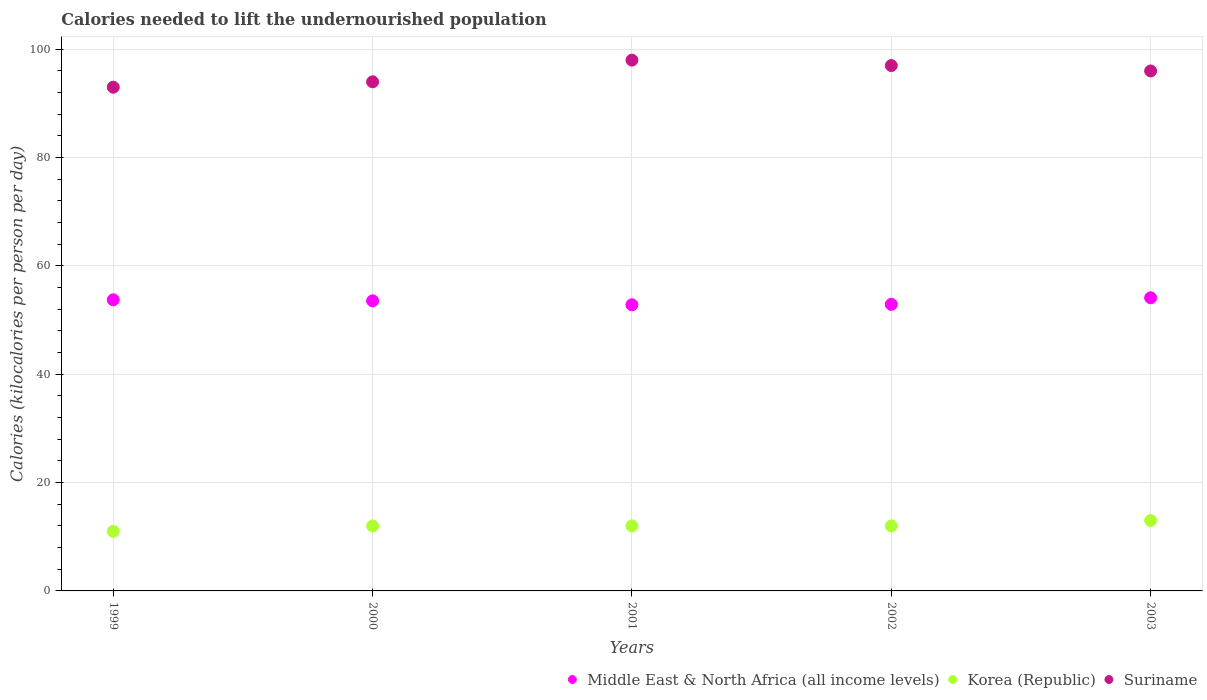What is the total calories needed to lift the undernourished population in Middle East & North Africa (all income levels) in 2001?
Your answer should be very brief. 52.83. Across all years, what is the maximum total calories needed to lift the undernourished population in Korea (Republic)?
Your answer should be very brief. 13. Across all years, what is the minimum total calories needed to lift the undernourished population in Suriname?
Provide a succinct answer. 93. In which year was the total calories needed to lift the undernourished population in Middle East & North Africa (all income levels) minimum?
Your answer should be compact. 2001. What is the total total calories needed to lift the undernourished population in Suriname in the graph?
Offer a very short reply. 478. What is the difference between the total calories needed to lift the undernourished population in Middle East & North Africa (all income levels) in 2002 and the total calories needed to lift the undernourished population in Korea (Republic) in 2000?
Keep it short and to the point. 40.91. In the year 2002, what is the difference between the total calories needed to lift the undernourished population in Middle East & North Africa (all income levels) and total calories needed to lift the undernourished population in Korea (Republic)?
Give a very brief answer. 40.91. What is the ratio of the total calories needed to lift the undernourished population in Suriname in 1999 to that in 2003?
Your answer should be compact. 0.97. What is the difference between the highest and the second highest total calories needed to lift the undernourished population in Middle East & North Africa (all income levels)?
Give a very brief answer. 0.37. What is the difference between the highest and the lowest total calories needed to lift the undernourished population in Korea (Republic)?
Offer a terse response. 2. In how many years, is the total calories needed to lift the undernourished population in Korea (Republic) greater than the average total calories needed to lift the undernourished population in Korea (Republic) taken over all years?
Provide a succinct answer. 1. Is the sum of the total calories needed to lift the undernourished population in Middle East & North Africa (all income levels) in 1999 and 2000 greater than the maximum total calories needed to lift the undernourished population in Korea (Republic) across all years?
Provide a short and direct response. Yes. Is the total calories needed to lift the undernourished population in Middle East & North Africa (all income levels) strictly less than the total calories needed to lift the undernourished population in Korea (Republic) over the years?
Ensure brevity in your answer.  No. How many dotlines are there?
Keep it short and to the point. 3. How many years are there in the graph?
Your answer should be compact. 5. Are the values on the major ticks of Y-axis written in scientific E-notation?
Your response must be concise. No. Does the graph contain any zero values?
Make the answer very short. No. Does the graph contain grids?
Your answer should be very brief. Yes. How many legend labels are there?
Provide a short and direct response. 3. What is the title of the graph?
Your answer should be very brief. Calories needed to lift the undernourished population. What is the label or title of the X-axis?
Provide a succinct answer. Years. What is the label or title of the Y-axis?
Ensure brevity in your answer.  Calories (kilocalories per person per day). What is the Calories (kilocalories per person per day) of Middle East & North Africa (all income levels) in 1999?
Your answer should be compact. 53.75. What is the Calories (kilocalories per person per day) of Korea (Republic) in 1999?
Keep it short and to the point. 11. What is the Calories (kilocalories per person per day) of Suriname in 1999?
Offer a very short reply. 93. What is the Calories (kilocalories per person per day) in Middle East & North Africa (all income levels) in 2000?
Your answer should be very brief. 53.56. What is the Calories (kilocalories per person per day) in Suriname in 2000?
Your answer should be very brief. 94. What is the Calories (kilocalories per person per day) of Middle East & North Africa (all income levels) in 2001?
Your answer should be very brief. 52.83. What is the Calories (kilocalories per person per day) of Suriname in 2001?
Give a very brief answer. 98. What is the Calories (kilocalories per person per day) of Middle East & North Africa (all income levels) in 2002?
Keep it short and to the point. 52.91. What is the Calories (kilocalories per person per day) in Suriname in 2002?
Provide a short and direct response. 97. What is the Calories (kilocalories per person per day) of Middle East & North Africa (all income levels) in 2003?
Your answer should be compact. 54.12. What is the Calories (kilocalories per person per day) of Korea (Republic) in 2003?
Ensure brevity in your answer.  13. What is the Calories (kilocalories per person per day) in Suriname in 2003?
Provide a short and direct response. 96. Across all years, what is the maximum Calories (kilocalories per person per day) of Middle East & North Africa (all income levels)?
Your answer should be compact. 54.12. Across all years, what is the minimum Calories (kilocalories per person per day) of Middle East & North Africa (all income levels)?
Your answer should be very brief. 52.83. Across all years, what is the minimum Calories (kilocalories per person per day) of Korea (Republic)?
Offer a terse response. 11. Across all years, what is the minimum Calories (kilocalories per person per day) of Suriname?
Ensure brevity in your answer.  93. What is the total Calories (kilocalories per person per day) in Middle East & North Africa (all income levels) in the graph?
Your response must be concise. 267.17. What is the total Calories (kilocalories per person per day) in Korea (Republic) in the graph?
Offer a very short reply. 60. What is the total Calories (kilocalories per person per day) in Suriname in the graph?
Offer a very short reply. 478. What is the difference between the Calories (kilocalories per person per day) of Middle East & North Africa (all income levels) in 1999 and that in 2000?
Make the answer very short. 0.19. What is the difference between the Calories (kilocalories per person per day) of Korea (Republic) in 1999 and that in 2000?
Ensure brevity in your answer.  -1. What is the difference between the Calories (kilocalories per person per day) of Middle East & North Africa (all income levels) in 1999 and that in 2001?
Offer a very short reply. 0.92. What is the difference between the Calories (kilocalories per person per day) in Middle East & North Africa (all income levels) in 1999 and that in 2002?
Ensure brevity in your answer.  0.84. What is the difference between the Calories (kilocalories per person per day) in Korea (Republic) in 1999 and that in 2002?
Provide a short and direct response. -1. What is the difference between the Calories (kilocalories per person per day) in Suriname in 1999 and that in 2002?
Ensure brevity in your answer.  -4. What is the difference between the Calories (kilocalories per person per day) of Middle East & North Africa (all income levels) in 1999 and that in 2003?
Offer a very short reply. -0.37. What is the difference between the Calories (kilocalories per person per day) of Suriname in 1999 and that in 2003?
Offer a terse response. -3. What is the difference between the Calories (kilocalories per person per day) in Middle East & North Africa (all income levels) in 2000 and that in 2001?
Your response must be concise. 0.72. What is the difference between the Calories (kilocalories per person per day) of Korea (Republic) in 2000 and that in 2001?
Provide a succinct answer. 0. What is the difference between the Calories (kilocalories per person per day) of Suriname in 2000 and that in 2001?
Give a very brief answer. -4. What is the difference between the Calories (kilocalories per person per day) of Middle East & North Africa (all income levels) in 2000 and that in 2002?
Ensure brevity in your answer.  0.65. What is the difference between the Calories (kilocalories per person per day) of Korea (Republic) in 2000 and that in 2002?
Provide a succinct answer. 0. What is the difference between the Calories (kilocalories per person per day) of Suriname in 2000 and that in 2002?
Your response must be concise. -3. What is the difference between the Calories (kilocalories per person per day) in Middle East & North Africa (all income levels) in 2000 and that in 2003?
Your answer should be very brief. -0.57. What is the difference between the Calories (kilocalories per person per day) in Korea (Republic) in 2000 and that in 2003?
Provide a short and direct response. -1. What is the difference between the Calories (kilocalories per person per day) of Middle East & North Africa (all income levels) in 2001 and that in 2002?
Offer a very short reply. -0.08. What is the difference between the Calories (kilocalories per person per day) in Suriname in 2001 and that in 2002?
Offer a very short reply. 1. What is the difference between the Calories (kilocalories per person per day) in Middle East & North Africa (all income levels) in 2001 and that in 2003?
Make the answer very short. -1.29. What is the difference between the Calories (kilocalories per person per day) in Suriname in 2001 and that in 2003?
Offer a very short reply. 2. What is the difference between the Calories (kilocalories per person per day) of Middle East & North Africa (all income levels) in 2002 and that in 2003?
Keep it short and to the point. -1.21. What is the difference between the Calories (kilocalories per person per day) of Middle East & North Africa (all income levels) in 1999 and the Calories (kilocalories per person per day) of Korea (Republic) in 2000?
Provide a succinct answer. 41.75. What is the difference between the Calories (kilocalories per person per day) of Middle East & North Africa (all income levels) in 1999 and the Calories (kilocalories per person per day) of Suriname in 2000?
Keep it short and to the point. -40.25. What is the difference between the Calories (kilocalories per person per day) in Korea (Republic) in 1999 and the Calories (kilocalories per person per day) in Suriname in 2000?
Your response must be concise. -83. What is the difference between the Calories (kilocalories per person per day) in Middle East & North Africa (all income levels) in 1999 and the Calories (kilocalories per person per day) in Korea (Republic) in 2001?
Offer a very short reply. 41.75. What is the difference between the Calories (kilocalories per person per day) of Middle East & North Africa (all income levels) in 1999 and the Calories (kilocalories per person per day) of Suriname in 2001?
Your response must be concise. -44.25. What is the difference between the Calories (kilocalories per person per day) in Korea (Republic) in 1999 and the Calories (kilocalories per person per day) in Suriname in 2001?
Make the answer very short. -87. What is the difference between the Calories (kilocalories per person per day) of Middle East & North Africa (all income levels) in 1999 and the Calories (kilocalories per person per day) of Korea (Republic) in 2002?
Offer a terse response. 41.75. What is the difference between the Calories (kilocalories per person per day) of Middle East & North Africa (all income levels) in 1999 and the Calories (kilocalories per person per day) of Suriname in 2002?
Your answer should be very brief. -43.25. What is the difference between the Calories (kilocalories per person per day) in Korea (Republic) in 1999 and the Calories (kilocalories per person per day) in Suriname in 2002?
Provide a short and direct response. -86. What is the difference between the Calories (kilocalories per person per day) of Middle East & North Africa (all income levels) in 1999 and the Calories (kilocalories per person per day) of Korea (Republic) in 2003?
Ensure brevity in your answer.  40.75. What is the difference between the Calories (kilocalories per person per day) in Middle East & North Africa (all income levels) in 1999 and the Calories (kilocalories per person per day) in Suriname in 2003?
Offer a terse response. -42.25. What is the difference between the Calories (kilocalories per person per day) of Korea (Republic) in 1999 and the Calories (kilocalories per person per day) of Suriname in 2003?
Keep it short and to the point. -85. What is the difference between the Calories (kilocalories per person per day) in Middle East & North Africa (all income levels) in 2000 and the Calories (kilocalories per person per day) in Korea (Republic) in 2001?
Your response must be concise. 41.56. What is the difference between the Calories (kilocalories per person per day) of Middle East & North Africa (all income levels) in 2000 and the Calories (kilocalories per person per day) of Suriname in 2001?
Provide a succinct answer. -44.44. What is the difference between the Calories (kilocalories per person per day) of Korea (Republic) in 2000 and the Calories (kilocalories per person per day) of Suriname in 2001?
Make the answer very short. -86. What is the difference between the Calories (kilocalories per person per day) in Middle East & North Africa (all income levels) in 2000 and the Calories (kilocalories per person per day) in Korea (Republic) in 2002?
Offer a very short reply. 41.56. What is the difference between the Calories (kilocalories per person per day) in Middle East & North Africa (all income levels) in 2000 and the Calories (kilocalories per person per day) in Suriname in 2002?
Provide a short and direct response. -43.44. What is the difference between the Calories (kilocalories per person per day) of Korea (Republic) in 2000 and the Calories (kilocalories per person per day) of Suriname in 2002?
Provide a succinct answer. -85. What is the difference between the Calories (kilocalories per person per day) of Middle East & North Africa (all income levels) in 2000 and the Calories (kilocalories per person per day) of Korea (Republic) in 2003?
Give a very brief answer. 40.56. What is the difference between the Calories (kilocalories per person per day) in Middle East & North Africa (all income levels) in 2000 and the Calories (kilocalories per person per day) in Suriname in 2003?
Keep it short and to the point. -42.44. What is the difference between the Calories (kilocalories per person per day) of Korea (Republic) in 2000 and the Calories (kilocalories per person per day) of Suriname in 2003?
Your answer should be compact. -84. What is the difference between the Calories (kilocalories per person per day) in Middle East & North Africa (all income levels) in 2001 and the Calories (kilocalories per person per day) in Korea (Republic) in 2002?
Provide a short and direct response. 40.83. What is the difference between the Calories (kilocalories per person per day) of Middle East & North Africa (all income levels) in 2001 and the Calories (kilocalories per person per day) of Suriname in 2002?
Offer a terse response. -44.17. What is the difference between the Calories (kilocalories per person per day) of Korea (Republic) in 2001 and the Calories (kilocalories per person per day) of Suriname in 2002?
Make the answer very short. -85. What is the difference between the Calories (kilocalories per person per day) in Middle East & North Africa (all income levels) in 2001 and the Calories (kilocalories per person per day) in Korea (Republic) in 2003?
Give a very brief answer. 39.83. What is the difference between the Calories (kilocalories per person per day) in Middle East & North Africa (all income levels) in 2001 and the Calories (kilocalories per person per day) in Suriname in 2003?
Ensure brevity in your answer.  -43.17. What is the difference between the Calories (kilocalories per person per day) in Korea (Republic) in 2001 and the Calories (kilocalories per person per day) in Suriname in 2003?
Provide a succinct answer. -84. What is the difference between the Calories (kilocalories per person per day) in Middle East & North Africa (all income levels) in 2002 and the Calories (kilocalories per person per day) in Korea (Republic) in 2003?
Keep it short and to the point. 39.91. What is the difference between the Calories (kilocalories per person per day) in Middle East & North Africa (all income levels) in 2002 and the Calories (kilocalories per person per day) in Suriname in 2003?
Your answer should be very brief. -43.09. What is the difference between the Calories (kilocalories per person per day) of Korea (Republic) in 2002 and the Calories (kilocalories per person per day) of Suriname in 2003?
Make the answer very short. -84. What is the average Calories (kilocalories per person per day) in Middle East & North Africa (all income levels) per year?
Keep it short and to the point. 53.43. What is the average Calories (kilocalories per person per day) of Korea (Republic) per year?
Your answer should be very brief. 12. What is the average Calories (kilocalories per person per day) of Suriname per year?
Your answer should be very brief. 95.6. In the year 1999, what is the difference between the Calories (kilocalories per person per day) of Middle East & North Africa (all income levels) and Calories (kilocalories per person per day) of Korea (Republic)?
Offer a terse response. 42.75. In the year 1999, what is the difference between the Calories (kilocalories per person per day) in Middle East & North Africa (all income levels) and Calories (kilocalories per person per day) in Suriname?
Make the answer very short. -39.25. In the year 1999, what is the difference between the Calories (kilocalories per person per day) of Korea (Republic) and Calories (kilocalories per person per day) of Suriname?
Give a very brief answer. -82. In the year 2000, what is the difference between the Calories (kilocalories per person per day) in Middle East & North Africa (all income levels) and Calories (kilocalories per person per day) in Korea (Republic)?
Provide a succinct answer. 41.56. In the year 2000, what is the difference between the Calories (kilocalories per person per day) in Middle East & North Africa (all income levels) and Calories (kilocalories per person per day) in Suriname?
Provide a succinct answer. -40.44. In the year 2000, what is the difference between the Calories (kilocalories per person per day) of Korea (Republic) and Calories (kilocalories per person per day) of Suriname?
Ensure brevity in your answer.  -82. In the year 2001, what is the difference between the Calories (kilocalories per person per day) in Middle East & North Africa (all income levels) and Calories (kilocalories per person per day) in Korea (Republic)?
Your response must be concise. 40.83. In the year 2001, what is the difference between the Calories (kilocalories per person per day) in Middle East & North Africa (all income levels) and Calories (kilocalories per person per day) in Suriname?
Provide a succinct answer. -45.17. In the year 2001, what is the difference between the Calories (kilocalories per person per day) in Korea (Republic) and Calories (kilocalories per person per day) in Suriname?
Provide a succinct answer. -86. In the year 2002, what is the difference between the Calories (kilocalories per person per day) in Middle East & North Africa (all income levels) and Calories (kilocalories per person per day) in Korea (Republic)?
Keep it short and to the point. 40.91. In the year 2002, what is the difference between the Calories (kilocalories per person per day) in Middle East & North Africa (all income levels) and Calories (kilocalories per person per day) in Suriname?
Offer a terse response. -44.09. In the year 2002, what is the difference between the Calories (kilocalories per person per day) in Korea (Republic) and Calories (kilocalories per person per day) in Suriname?
Offer a very short reply. -85. In the year 2003, what is the difference between the Calories (kilocalories per person per day) in Middle East & North Africa (all income levels) and Calories (kilocalories per person per day) in Korea (Republic)?
Ensure brevity in your answer.  41.12. In the year 2003, what is the difference between the Calories (kilocalories per person per day) of Middle East & North Africa (all income levels) and Calories (kilocalories per person per day) of Suriname?
Offer a terse response. -41.88. In the year 2003, what is the difference between the Calories (kilocalories per person per day) of Korea (Republic) and Calories (kilocalories per person per day) of Suriname?
Make the answer very short. -83. What is the ratio of the Calories (kilocalories per person per day) of Korea (Republic) in 1999 to that in 2000?
Offer a very short reply. 0.92. What is the ratio of the Calories (kilocalories per person per day) in Middle East & North Africa (all income levels) in 1999 to that in 2001?
Your response must be concise. 1.02. What is the ratio of the Calories (kilocalories per person per day) in Suriname in 1999 to that in 2001?
Make the answer very short. 0.95. What is the ratio of the Calories (kilocalories per person per day) in Middle East & North Africa (all income levels) in 1999 to that in 2002?
Give a very brief answer. 1.02. What is the ratio of the Calories (kilocalories per person per day) of Korea (Republic) in 1999 to that in 2002?
Provide a succinct answer. 0.92. What is the ratio of the Calories (kilocalories per person per day) in Suriname in 1999 to that in 2002?
Offer a terse response. 0.96. What is the ratio of the Calories (kilocalories per person per day) in Middle East & North Africa (all income levels) in 1999 to that in 2003?
Give a very brief answer. 0.99. What is the ratio of the Calories (kilocalories per person per day) in Korea (Republic) in 1999 to that in 2003?
Offer a very short reply. 0.85. What is the ratio of the Calories (kilocalories per person per day) of Suriname in 1999 to that in 2003?
Ensure brevity in your answer.  0.97. What is the ratio of the Calories (kilocalories per person per day) in Middle East & North Africa (all income levels) in 2000 to that in 2001?
Ensure brevity in your answer.  1.01. What is the ratio of the Calories (kilocalories per person per day) of Suriname in 2000 to that in 2001?
Your answer should be very brief. 0.96. What is the ratio of the Calories (kilocalories per person per day) in Middle East & North Africa (all income levels) in 2000 to that in 2002?
Offer a very short reply. 1.01. What is the ratio of the Calories (kilocalories per person per day) in Korea (Republic) in 2000 to that in 2002?
Make the answer very short. 1. What is the ratio of the Calories (kilocalories per person per day) in Suriname in 2000 to that in 2002?
Provide a short and direct response. 0.97. What is the ratio of the Calories (kilocalories per person per day) of Korea (Republic) in 2000 to that in 2003?
Your response must be concise. 0.92. What is the ratio of the Calories (kilocalories per person per day) in Suriname in 2000 to that in 2003?
Offer a terse response. 0.98. What is the ratio of the Calories (kilocalories per person per day) in Korea (Republic) in 2001 to that in 2002?
Make the answer very short. 1. What is the ratio of the Calories (kilocalories per person per day) of Suriname in 2001 to that in 2002?
Ensure brevity in your answer.  1.01. What is the ratio of the Calories (kilocalories per person per day) in Middle East & North Africa (all income levels) in 2001 to that in 2003?
Give a very brief answer. 0.98. What is the ratio of the Calories (kilocalories per person per day) in Korea (Republic) in 2001 to that in 2003?
Keep it short and to the point. 0.92. What is the ratio of the Calories (kilocalories per person per day) in Suriname in 2001 to that in 2003?
Your response must be concise. 1.02. What is the ratio of the Calories (kilocalories per person per day) in Middle East & North Africa (all income levels) in 2002 to that in 2003?
Make the answer very short. 0.98. What is the ratio of the Calories (kilocalories per person per day) of Korea (Republic) in 2002 to that in 2003?
Your response must be concise. 0.92. What is the ratio of the Calories (kilocalories per person per day) of Suriname in 2002 to that in 2003?
Your answer should be compact. 1.01. What is the difference between the highest and the second highest Calories (kilocalories per person per day) of Middle East & North Africa (all income levels)?
Keep it short and to the point. 0.37. What is the difference between the highest and the second highest Calories (kilocalories per person per day) in Korea (Republic)?
Offer a very short reply. 1. What is the difference between the highest and the second highest Calories (kilocalories per person per day) of Suriname?
Provide a short and direct response. 1. What is the difference between the highest and the lowest Calories (kilocalories per person per day) of Middle East & North Africa (all income levels)?
Ensure brevity in your answer.  1.29. 